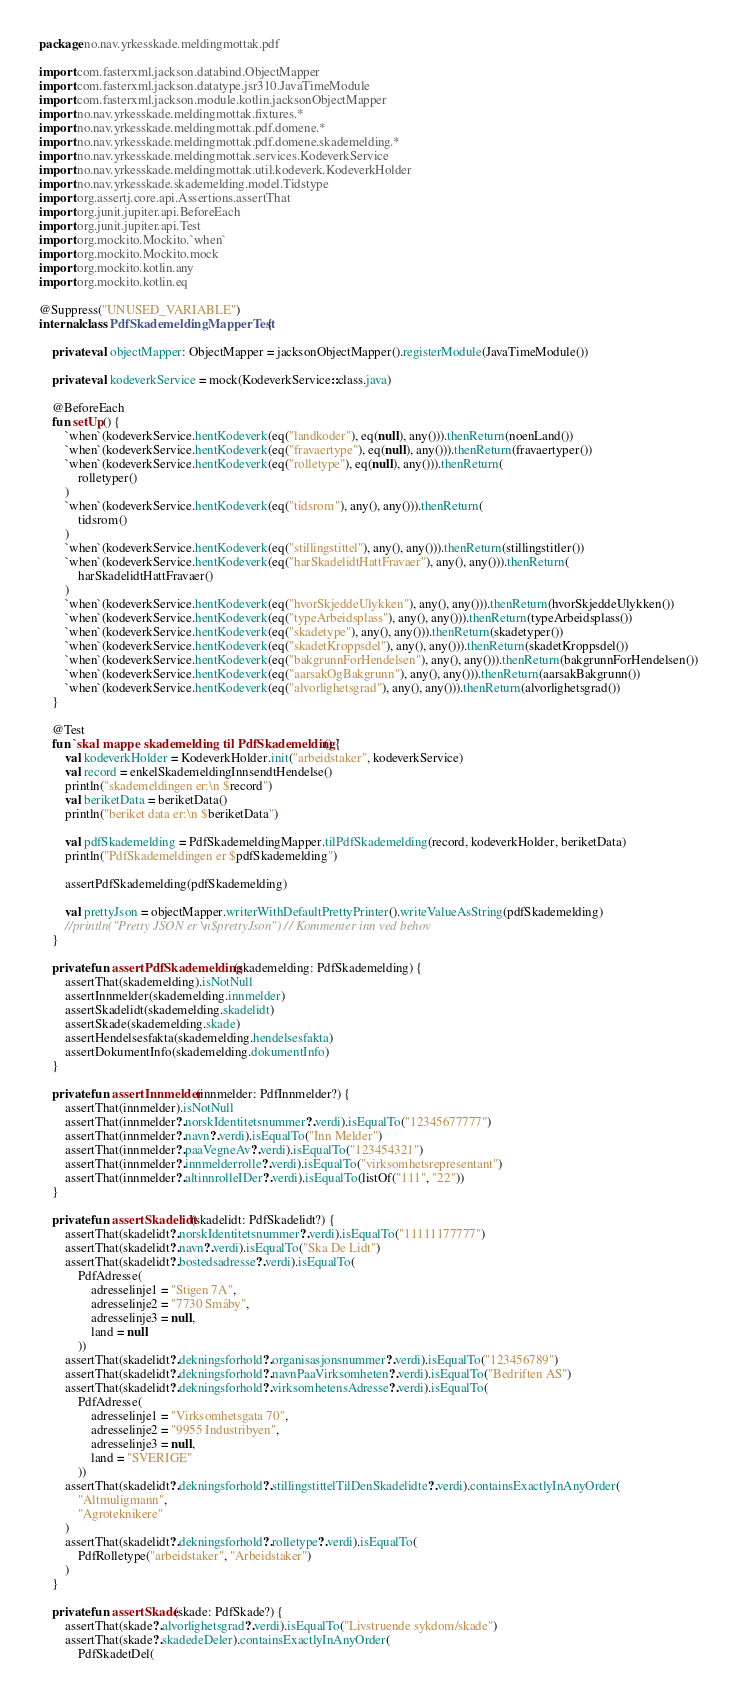Convert code to text. <code><loc_0><loc_0><loc_500><loc_500><_Kotlin_>package no.nav.yrkesskade.meldingmottak.pdf

import com.fasterxml.jackson.databind.ObjectMapper
import com.fasterxml.jackson.datatype.jsr310.JavaTimeModule
import com.fasterxml.jackson.module.kotlin.jacksonObjectMapper
import no.nav.yrkesskade.meldingmottak.fixtures.*
import no.nav.yrkesskade.meldingmottak.pdf.domene.*
import no.nav.yrkesskade.meldingmottak.pdf.domene.skademelding.*
import no.nav.yrkesskade.meldingmottak.services.KodeverkService
import no.nav.yrkesskade.meldingmottak.util.kodeverk.KodeverkHolder
import no.nav.yrkesskade.skademelding.model.Tidstype
import org.assertj.core.api.Assertions.assertThat
import org.junit.jupiter.api.BeforeEach
import org.junit.jupiter.api.Test
import org.mockito.Mockito.`when`
import org.mockito.Mockito.mock
import org.mockito.kotlin.any
import org.mockito.kotlin.eq

@Suppress("UNUSED_VARIABLE")
internal class PdfSkademeldingMapperTest {

    private val objectMapper: ObjectMapper = jacksonObjectMapper().registerModule(JavaTimeModule())

    private val kodeverkService = mock(KodeverkService::class.java)

    @BeforeEach
    fun setUp() {
        `when`(kodeverkService.hentKodeverk(eq("landkoder"), eq(null), any())).thenReturn(noenLand())
        `when`(kodeverkService.hentKodeverk(eq("fravaertype"), eq(null), any())).thenReturn(fravaertyper())
        `when`(kodeverkService.hentKodeverk(eq("rolletype"), eq(null), any())).thenReturn(
            rolletyper()
        )
        `when`(kodeverkService.hentKodeverk(eq("tidsrom"), any(), any())).thenReturn(
            tidsrom()
        )
        `when`(kodeverkService.hentKodeverk(eq("stillingstittel"), any(), any())).thenReturn(stillingstitler())
        `when`(kodeverkService.hentKodeverk(eq("harSkadelidtHattFravaer"), any(), any())).thenReturn(
            harSkadelidtHattFravaer()
        )
        `when`(kodeverkService.hentKodeverk(eq("hvorSkjeddeUlykken"), any(), any())).thenReturn(hvorSkjeddeUlykken())
        `when`(kodeverkService.hentKodeverk(eq("typeArbeidsplass"), any(), any())).thenReturn(typeArbeidsplass())
        `when`(kodeverkService.hentKodeverk(eq("skadetype"), any(), any())).thenReturn(skadetyper())
        `when`(kodeverkService.hentKodeverk(eq("skadetKroppsdel"), any(), any())).thenReturn(skadetKroppsdel())
        `when`(kodeverkService.hentKodeverk(eq("bakgrunnForHendelsen"), any(), any())).thenReturn(bakgrunnForHendelsen())
        `when`(kodeverkService.hentKodeverk(eq("aarsakOgBakgrunn"), any(), any())).thenReturn(aarsakBakgrunn())
        `when`(kodeverkService.hentKodeverk(eq("alvorlighetsgrad"), any(), any())).thenReturn(alvorlighetsgrad())
    }

    @Test
    fun `skal mappe skademelding til PdfSkademelding`() {
        val kodeverkHolder = KodeverkHolder.init("arbeidstaker", kodeverkService)
        val record = enkelSkademeldingInnsendtHendelse()
        println("skademeldingen er:\n $record")
        val beriketData = beriketData()
        println("beriket data er:\n $beriketData")

        val pdfSkademelding = PdfSkademeldingMapper.tilPdfSkademelding(record, kodeverkHolder, beriketData)
        println("PdfSkademeldingen er $pdfSkademelding")

        assertPdfSkademelding(pdfSkademelding)

        val prettyJson = objectMapper.writerWithDefaultPrettyPrinter().writeValueAsString(pdfSkademelding)
        //println("Pretty JSON er \n$prettyJson") // Kommenter inn ved behov
    }

    private fun assertPdfSkademelding(skademelding: PdfSkademelding) {
        assertThat(skademelding).isNotNull
        assertInnmelder(skademelding.innmelder)
        assertSkadelidt(skademelding.skadelidt)
        assertSkade(skademelding.skade)
        assertHendelsesfakta(skademelding.hendelsesfakta)
        assertDokumentInfo(skademelding.dokumentInfo)
    }

    private fun assertInnmelder(innmelder: PdfInnmelder?) {
        assertThat(innmelder).isNotNull
        assertThat(innmelder?.norskIdentitetsnummer?.verdi).isEqualTo("12345677777")
        assertThat(innmelder?.navn?.verdi).isEqualTo("Inn Melder")
        assertThat(innmelder?.paaVegneAv?.verdi).isEqualTo("123454321")
        assertThat(innmelder?.innmelderrolle?.verdi).isEqualTo("virksomhetsrepresentant")
        assertThat(innmelder?.altinnrolleIDer?.verdi).isEqualTo(listOf("111", "22"))
    }

    private fun assertSkadelidt(skadelidt: PdfSkadelidt?) {
        assertThat(skadelidt?.norskIdentitetsnummer?.verdi).isEqualTo("11111177777")
        assertThat(skadelidt?.navn?.verdi).isEqualTo("Ska De Lidt")
        assertThat(skadelidt?.bostedsadresse?.verdi).isEqualTo(
            PdfAdresse(
                adresselinje1 = "Stigen 7A",
                adresselinje2 = "7730 Småby",
                adresselinje3 = null,
                land = null
            ))
        assertThat(skadelidt?.dekningsforhold?.organisasjonsnummer?.verdi).isEqualTo("123456789")
        assertThat(skadelidt?.dekningsforhold?.navnPaaVirksomheten?.verdi).isEqualTo("Bedriften AS")
        assertThat(skadelidt?.dekningsforhold?.virksomhetensAdresse?.verdi).isEqualTo(
            PdfAdresse(
                adresselinje1 = "Virksomhetsgata 70",
                adresselinje2 = "9955 Industribyen",
                adresselinje3 = null,
                land = "SVERIGE"
            ))
        assertThat(skadelidt?.dekningsforhold?.stillingstittelTilDenSkadelidte?.verdi).containsExactlyInAnyOrder(
            "Altmuligmann",
            "Agroteknikere"
        )
        assertThat(skadelidt?.dekningsforhold?.rolletype?.verdi).isEqualTo(
            PdfRolletype("arbeidstaker", "Arbeidstaker")
        )
    }

    private fun assertSkade(skade: PdfSkade?) {
        assertThat(skade?.alvorlighetsgrad?.verdi).isEqualTo("Livstruende sykdom/skade")
        assertThat(skade?.skadedeDeler).containsExactlyInAnyOrder(
            PdfSkadetDel(</code> 